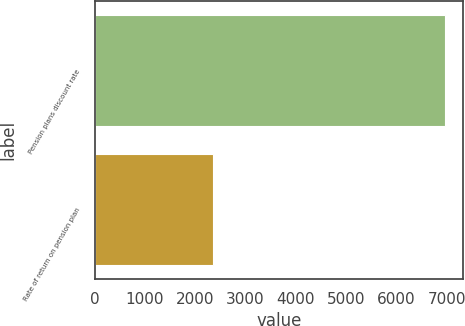Convert chart to OTSL. <chart><loc_0><loc_0><loc_500><loc_500><bar_chart><fcel>Pension plans discount rate<fcel>Rate of return on pension plan<nl><fcel>6969<fcel>2343<nl></chart> 